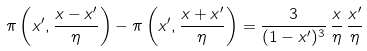Convert formula to latex. <formula><loc_0><loc_0><loc_500><loc_500>\pi \left ( x ^ { \prime } , \frac { x - x ^ { \prime } } { \eta } \right ) - \pi \left ( x ^ { \prime } , \frac { x + x ^ { \prime } } { \eta } \right ) = \frac { 3 } { ( 1 - x ^ { \prime } ) ^ { 3 } } \, \frac { x } { \eta } \, \frac { x ^ { \prime } } { \eta }</formula> 